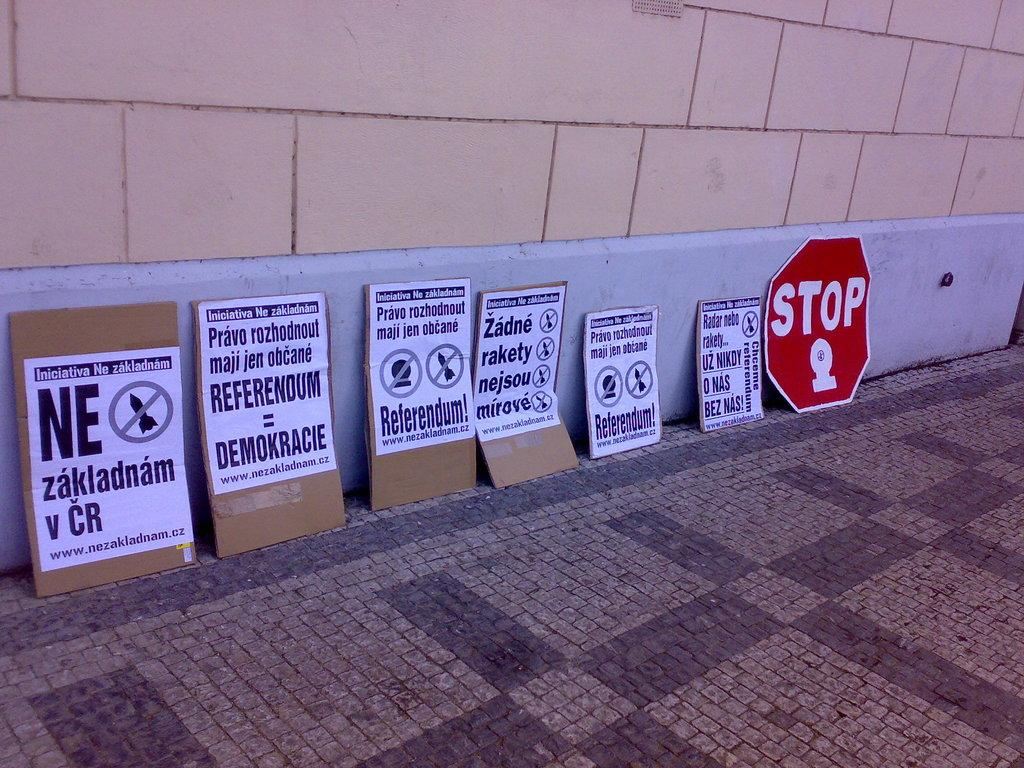<image>
Write a terse but informative summary of the picture. A group of several signs are lined up against a wall, one says Referendum! and another STOP. 